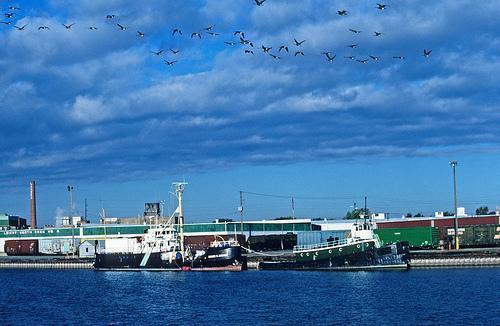How many boats are in the picture?
Give a very brief answer. 2. 